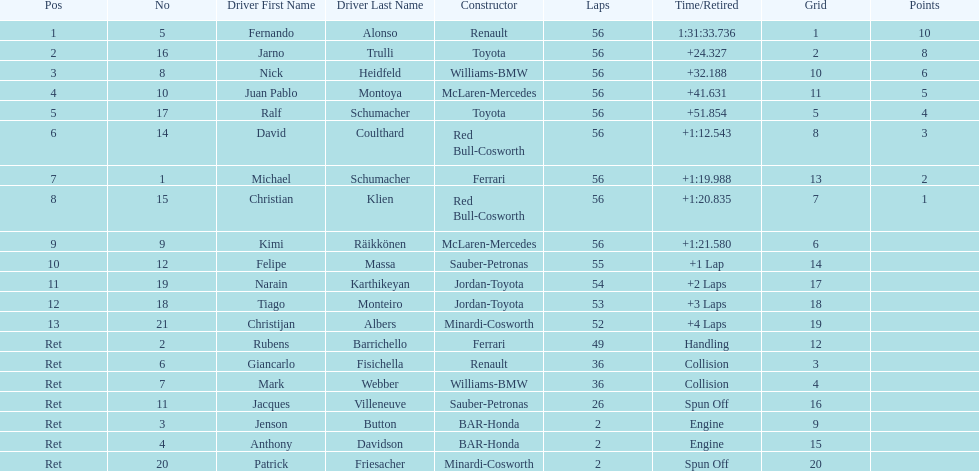Jarno trulli was not french but what nationality? Italian. 